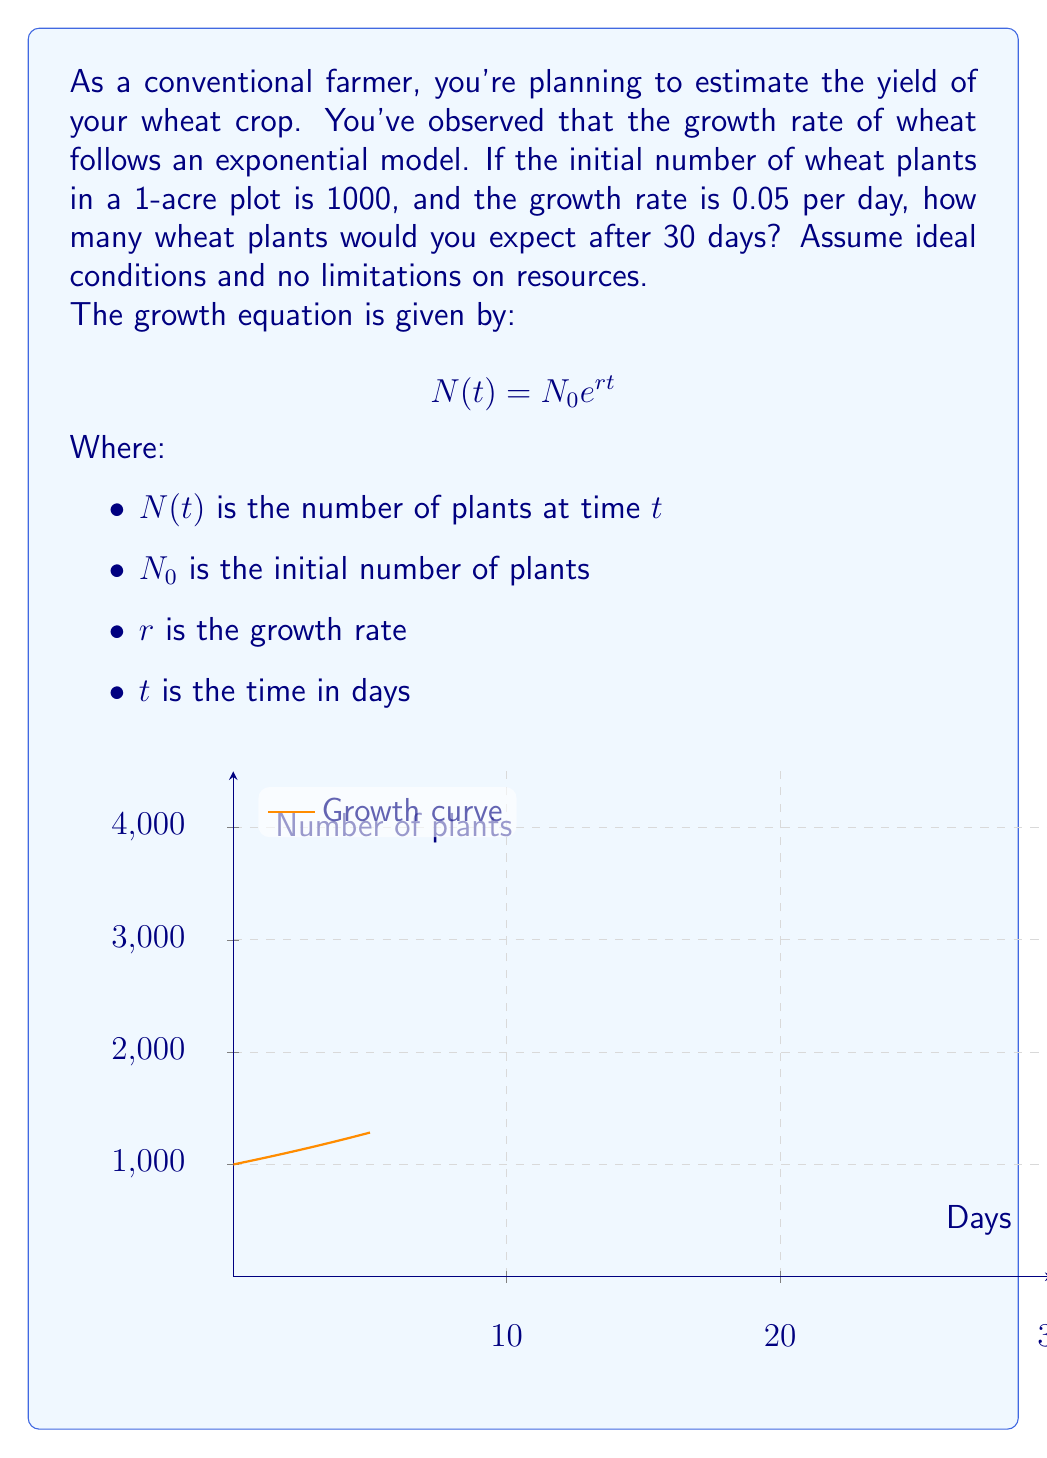What is the answer to this math problem? To solve this problem, we'll use the exponential growth equation and plug in the given values:

1) We're given:
   $N_0 = 1000$ (initial number of plants)
   $r = 0.05$ (growth rate per day)
   $t = 30$ (days)

2) Let's substitute these values into the equation:

   $$ N(t) = N_0 e^{rt} $$
   $$ N(30) = 1000 e^{0.05 \times 30} $$

3) Now, let's calculate:
   $$ N(30) = 1000 e^{1.5} $$

4) Using a calculator or computer to evaluate $e^{1.5}$:
   $$ N(30) = 1000 \times 4.4816 $$

5) Multiply:
   $$ N(30) = 4481.6 $$

6) Since we're dealing with whole plants, we'll round to the nearest whole number:
   $$ N(30) \approx 4482 \text{ plants} $$

Therefore, after 30 days, you would expect approximately 4482 wheat plants in your 1-acre plot.
Answer: 4482 plants 